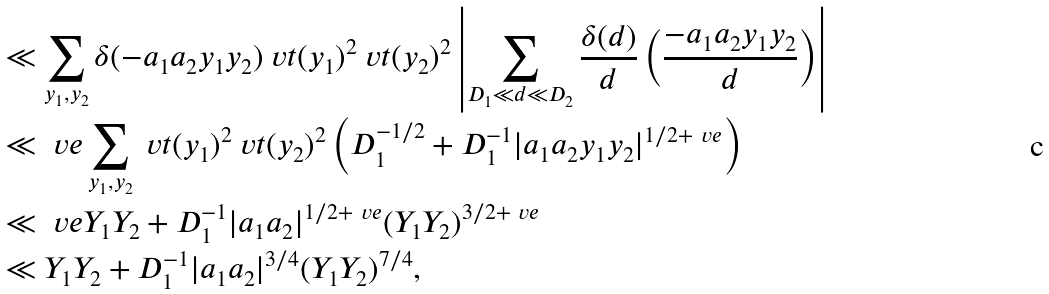<formula> <loc_0><loc_0><loc_500><loc_500>& \ll \sum _ { y _ { 1 } , y _ { 2 } } \delta ( - a _ { 1 } a _ { 2 } y _ { 1 } y _ { 2 } ) \ v t ( y _ { 1 } ) ^ { 2 } \ v t ( y _ { 2 } ) ^ { 2 } \left | \sum _ { D _ { 1 } \ll d \ll D _ { 2 } } \frac { \delta ( d ) } { d } \left ( \frac { - a _ { 1 } a _ { 2 } y _ { 1 } y _ { 2 } } { d } \right ) \right | \\ & \ll _ { \ } v e \sum _ { y _ { 1 } , y _ { 2 } } \ v t ( y _ { 1 } ) ^ { 2 } \ v t ( y _ { 2 } ) ^ { 2 } \left ( D _ { 1 } ^ { - 1 / 2 } + D _ { 1 } ^ { - 1 } | a _ { 1 } a _ { 2 } y _ { 1 } y _ { 2 } | ^ { 1 / 2 + \ v e } \right ) \\ & \ll _ { \ } v e Y _ { 1 } Y _ { 2 } + D _ { 1 } ^ { - 1 } | a _ { 1 } a _ { 2 } | ^ { 1 / 2 + \ v e } ( Y _ { 1 } Y _ { 2 } ) ^ { 3 / 2 + \ v e } \\ & \ll Y _ { 1 } Y _ { 2 } + D _ { 1 } ^ { - 1 } | a _ { 1 } a _ { 2 } | ^ { 3 / 4 } ( Y _ { 1 } Y _ { 2 } ) ^ { 7 / 4 } ,</formula> 